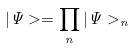Convert formula to latex. <formula><loc_0><loc_0><loc_500><loc_500>| \Psi > = \prod _ { n } | \Psi > _ { n }</formula> 